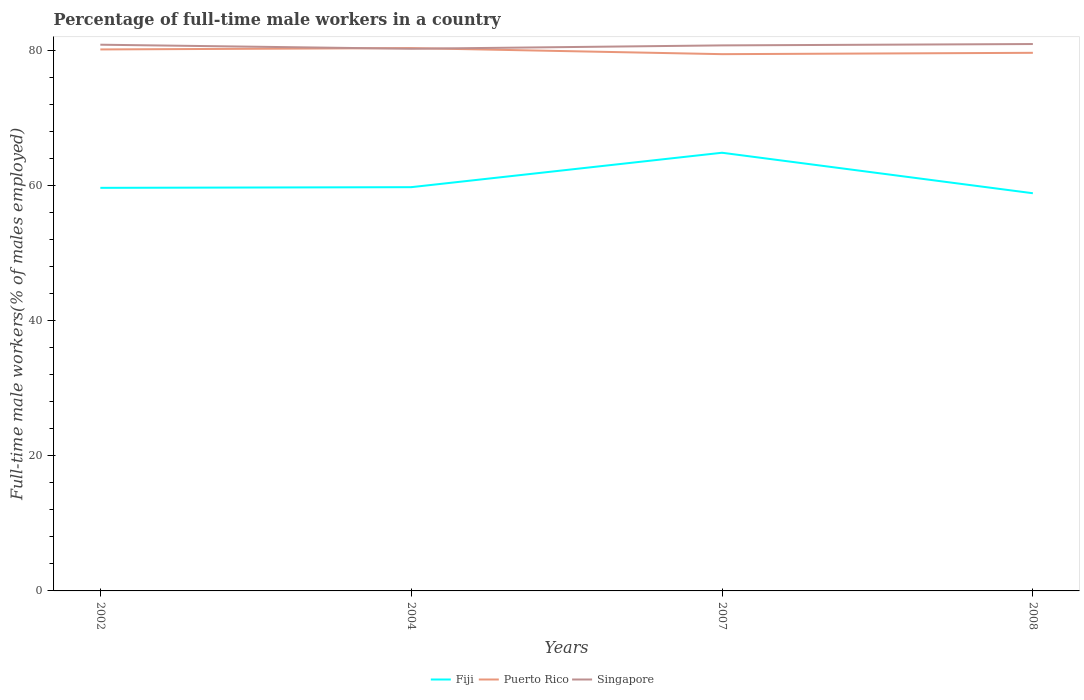Does the line corresponding to Singapore intersect with the line corresponding to Puerto Rico?
Your answer should be very brief. Yes. Across all years, what is the maximum percentage of full-time male workers in Puerto Rico?
Your answer should be very brief. 79.5. In which year was the percentage of full-time male workers in Singapore maximum?
Make the answer very short. 2004. What is the total percentage of full-time male workers in Fiji in the graph?
Provide a succinct answer. -5.2. What is the difference between the highest and the second highest percentage of full-time male workers in Singapore?
Offer a terse response. 0.7. Is the percentage of full-time male workers in Puerto Rico strictly greater than the percentage of full-time male workers in Singapore over the years?
Offer a very short reply. No. Are the values on the major ticks of Y-axis written in scientific E-notation?
Offer a terse response. No. Where does the legend appear in the graph?
Keep it short and to the point. Bottom center. How are the legend labels stacked?
Give a very brief answer. Horizontal. What is the title of the graph?
Your answer should be very brief. Percentage of full-time male workers in a country. What is the label or title of the X-axis?
Make the answer very short. Years. What is the label or title of the Y-axis?
Your answer should be very brief. Full-time male workers(% of males employed). What is the Full-time male workers(% of males employed) in Fiji in 2002?
Offer a terse response. 59.7. What is the Full-time male workers(% of males employed) in Puerto Rico in 2002?
Give a very brief answer. 80.2. What is the Full-time male workers(% of males employed) of Singapore in 2002?
Your response must be concise. 80.9. What is the Full-time male workers(% of males employed) of Fiji in 2004?
Keep it short and to the point. 59.8. What is the Full-time male workers(% of males employed) of Puerto Rico in 2004?
Offer a terse response. 80.4. What is the Full-time male workers(% of males employed) in Singapore in 2004?
Make the answer very short. 80.3. What is the Full-time male workers(% of males employed) of Fiji in 2007?
Provide a succinct answer. 64.9. What is the Full-time male workers(% of males employed) in Puerto Rico in 2007?
Provide a short and direct response. 79.5. What is the Full-time male workers(% of males employed) in Singapore in 2007?
Ensure brevity in your answer.  80.8. What is the Full-time male workers(% of males employed) of Fiji in 2008?
Offer a very short reply. 58.9. What is the Full-time male workers(% of males employed) of Puerto Rico in 2008?
Ensure brevity in your answer.  79.7. What is the Full-time male workers(% of males employed) in Singapore in 2008?
Offer a terse response. 81. Across all years, what is the maximum Full-time male workers(% of males employed) in Fiji?
Make the answer very short. 64.9. Across all years, what is the maximum Full-time male workers(% of males employed) in Puerto Rico?
Your answer should be compact. 80.4. Across all years, what is the maximum Full-time male workers(% of males employed) in Singapore?
Offer a terse response. 81. Across all years, what is the minimum Full-time male workers(% of males employed) of Fiji?
Provide a short and direct response. 58.9. Across all years, what is the minimum Full-time male workers(% of males employed) of Puerto Rico?
Ensure brevity in your answer.  79.5. Across all years, what is the minimum Full-time male workers(% of males employed) of Singapore?
Your response must be concise. 80.3. What is the total Full-time male workers(% of males employed) of Fiji in the graph?
Make the answer very short. 243.3. What is the total Full-time male workers(% of males employed) of Puerto Rico in the graph?
Provide a short and direct response. 319.8. What is the total Full-time male workers(% of males employed) in Singapore in the graph?
Your response must be concise. 323. What is the difference between the Full-time male workers(% of males employed) in Puerto Rico in 2002 and that in 2004?
Make the answer very short. -0.2. What is the difference between the Full-time male workers(% of males employed) in Fiji in 2002 and that in 2007?
Ensure brevity in your answer.  -5.2. What is the difference between the Full-time male workers(% of males employed) of Puerto Rico in 2002 and that in 2007?
Your answer should be very brief. 0.7. What is the difference between the Full-time male workers(% of males employed) in Fiji in 2002 and that in 2008?
Provide a succinct answer. 0.8. What is the difference between the Full-time male workers(% of males employed) in Singapore in 2002 and that in 2008?
Provide a short and direct response. -0.1. What is the difference between the Full-time male workers(% of males employed) in Fiji in 2004 and that in 2007?
Offer a very short reply. -5.1. What is the difference between the Full-time male workers(% of males employed) in Puerto Rico in 2004 and that in 2007?
Ensure brevity in your answer.  0.9. What is the difference between the Full-time male workers(% of males employed) in Fiji in 2004 and that in 2008?
Ensure brevity in your answer.  0.9. What is the difference between the Full-time male workers(% of males employed) of Puerto Rico in 2004 and that in 2008?
Give a very brief answer. 0.7. What is the difference between the Full-time male workers(% of males employed) of Puerto Rico in 2007 and that in 2008?
Give a very brief answer. -0.2. What is the difference between the Full-time male workers(% of males employed) of Singapore in 2007 and that in 2008?
Provide a short and direct response. -0.2. What is the difference between the Full-time male workers(% of males employed) of Fiji in 2002 and the Full-time male workers(% of males employed) of Puerto Rico in 2004?
Ensure brevity in your answer.  -20.7. What is the difference between the Full-time male workers(% of males employed) in Fiji in 2002 and the Full-time male workers(% of males employed) in Singapore in 2004?
Keep it short and to the point. -20.6. What is the difference between the Full-time male workers(% of males employed) of Fiji in 2002 and the Full-time male workers(% of males employed) of Puerto Rico in 2007?
Offer a very short reply. -19.8. What is the difference between the Full-time male workers(% of males employed) in Fiji in 2002 and the Full-time male workers(% of males employed) in Singapore in 2007?
Your response must be concise. -21.1. What is the difference between the Full-time male workers(% of males employed) in Puerto Rico in 2002 and the Full-time male workers(% of males employed) in Singapore in 2007?
Make the answer very short. -0.6. What is the difference between the Full-time male workers(% of males employed) of Fiji in 2002 and the Full-time male workers(% of males employed) of Singapore in 2008?
Offer a very short reply. -21.3. What is the difference between the Full-time male workers(% of males employed) of Puerto Rico in 2002 and the Full-time male workers(% of males employed) of Singapore in 2008?
Offer a terse response. -0.8. What is the difference between the Full-time male workers(% of males employed) in Fiji in 2004 and the Full-time male workers(% of males employed) in Puerto Rico in 2007?
Make the answer very short. -19.7. What is the difference between the Full-time male workers(% of males employed) in Puerto Rico in 2004 and the Full-time male workers(% of males employed) in Singapore in 2007?
Give a very brief answer. -0.4. What is the difference between the Full-time male workers(% of males employed) in Fiji in 2004 and the Full-time male workers(% of males employed) in Puerto Rico in 2008?
Your answer should be very brief. -19.9. What is the difference between the Full-time male workers(% of males employed) of Fiji in 2004 and the Full-time male workers(% of males employed) of Singapore in 2008?
Offer a terse response. -21.2. What is the difference between the Full-time male workers(% of males employed) in Fiji in 2007 and the Full-time male workers(% of males employed) in Puerto Rico in 2008?
Your answer should be very brief. -14.8. What is the difference between the Full-time male workers(% of males employed) in Fiji in 2007 and the Full-time male workers(% of males employed) in Singapore in 2008?
Give a very brief answer. -16.1. What is the average Full-time male workers(% of males employed) in Fiji per year?
Keep it short and to the point. 60.83. What is the average Full-time male workers(% of males employed) in Puerto Rico per year?
Keep it short and to the point. 79.95. What is the average Full-time male workers(% of males employed) of Singapore per year?
Give a very brief answer. 80.75. In the year 2002, what is the difference between the Full-time male workers(% of males employed) of Fiji and Full-time male workers(% of males employed) of Puerto Rico?
Ensure brevity in your answer.  -20.5. In the year 2002, what is the difference between the Full-time male workers(% of males employed) in Fiji and Full-time male workers(% of males employed) in Singapore?
Provide a short and direct response. -21.2. In the year 2002, what is the difference between the Full-time male workers(% of males employed) in Puerto Rico and Full-time male workers(% of males employed) in Singapore?
Your response must be concise. -0.7. In the year 2004, what is the difference between the Full-time male workers(% of males employed) in Fiji and Full-time male workers(% of males employed) in Puerto Rico?
Ensure brevity in your answer.  -20.6. In the year 2004, what is the difference between the Full-time male workers(% of males employed) in Fiji and Full-time male workers(% of males employed) in Singapore?
Your answer should be compact. -20.5. In the year 2004, what is the difference between the Full-time male workers(% of males employed) of Puerto Rico and Full-time male workers(% of males employed) of Singapore?
Offer a terse response. 0.1. In the year 2007, what is the difference between the Full-time male workers(% of males employed) of Fiji and Full-time male workers(% of males employed) of Puerto Rico?
Your response must be concise. -14.6. In the year 2007, what is the difference between the Full-time male workers(% of males employed) of Fiji and Full-time male workers(% of males employed) of Singapore?
Provide a succinct answer. -15.9. In the year 2007, what is the difference between the Full-time male workers(% of males employed) of Puerto Rico and Full-time male workers(% of males employed) of Singapore?
Ensure brevity in your answer.  -1.3. In the year 2008, what is the difference between the Full-time male workers(% of males employed) of Fiji and Full-time male workers(% of males employed) of Puerto Rico?
Offer a very short reply. -20.8. In the year 2008, what is the difference between the Full-time male workers(% of males employed) in Fiji and Full-time male workers(% of males employed) in Singapore?
Provide a succinct answer. -22.1. In the year 2008, what is the difference between the Full-time male workers(% of males employed) of Puerto Rico and Full-time male workers(% of males employed) of Singapore?
Your response must be concise. -1.3. What is the ratio of the Full-time male workers(% of males employed) in Fiji in 2002 to that in 2004?
Keep it short and to the point. 1. What is the ratio of the Full-time male workers(% of males employed) of Singapore in 2002 to that in 2004?
Offer a terse response. 1.01. What is the ratio of the Full-time male workers(% of males employed) of Fiji in 2002 to that in 2007?
Your response must be concise. 0.92. What is the ratio of the Full-time male workers(% of males employed) of Puerto Rico in 2002 to that in 2007?
Provide a short and direct response. 1.01. What is the ratio of the Full-time male workers(% of males employed) in Fiji in 2002 to that in 2008?
Your response must be concise. 1.01. What is the ratio of the Full-time male workers(% of males employed) in Fiji in 2004 to that in 2007?
Offer a very short reply. 0.92. What is the ratio of the Full-time male workers(% of males employed) of Puerto Rico in 2004 to that in 2007?
Offer a very short reply. 1.01. What is the ratio of the Full-time male workers(% of males employed) of Fiji in 2004 to that in 2008?
Your answer should be compact. 1.02. What is the ratio of the Full-time male workers(% of males employed) of Puerto Rico in 2004 to that in 2008?
Offer a terse response. 1.01. What is the ratio of the Full-time male workers(% of males employed) in Fiji in 2007 to that in 2008?
Make the answer very short. 1.1. What is the difference between the highest and the second highest Full-time male workers(% of males employed) of Puerto Rico?
Your answer should be very brief. 0.2. What is the difference between the highest and the second highest Full-time male workers(% of males employed) in Singapore?
Offer a terse response. 0.1. What is the difference between the highest and the lowest Full-time male workers(% of males employed) in Singapore?
Offer a terse response. 0.7. 